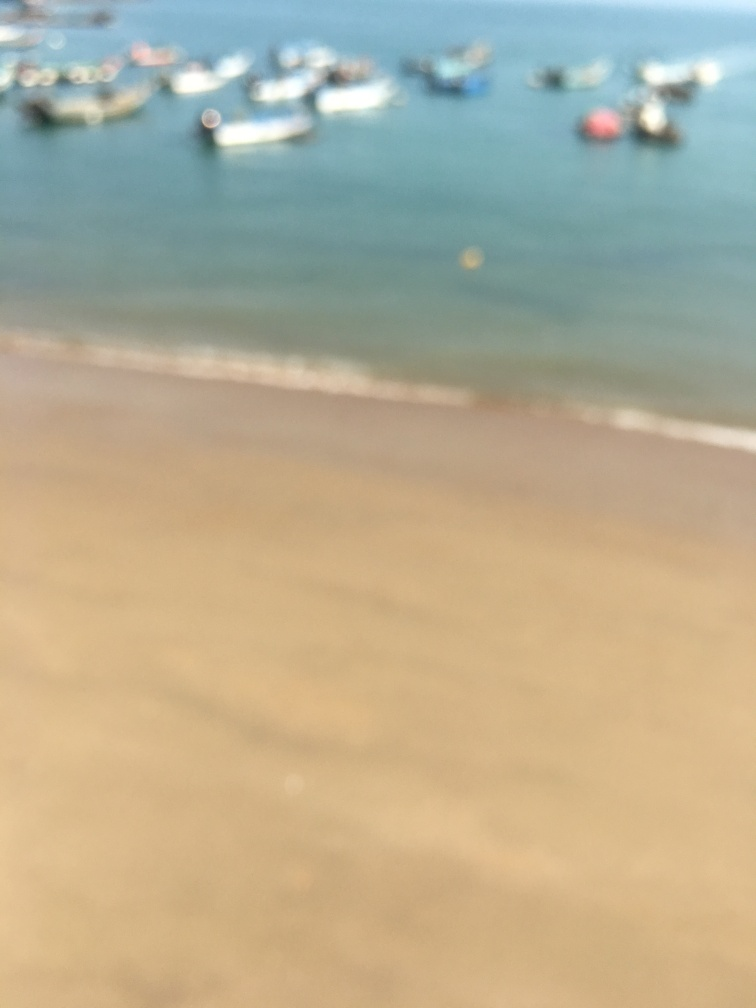What emotions might this image evoke, taking into account its lack of focus? Images like this one can evoke a sense of nostalgia or introspection, as the blurriness might symbolize memory's imperfect nature or the passage of time. It might also encourage a form of peacefulness or relaxation, as the undefined details allow the viewer to fill in the blanks with personal interpretation or daydreaming. 